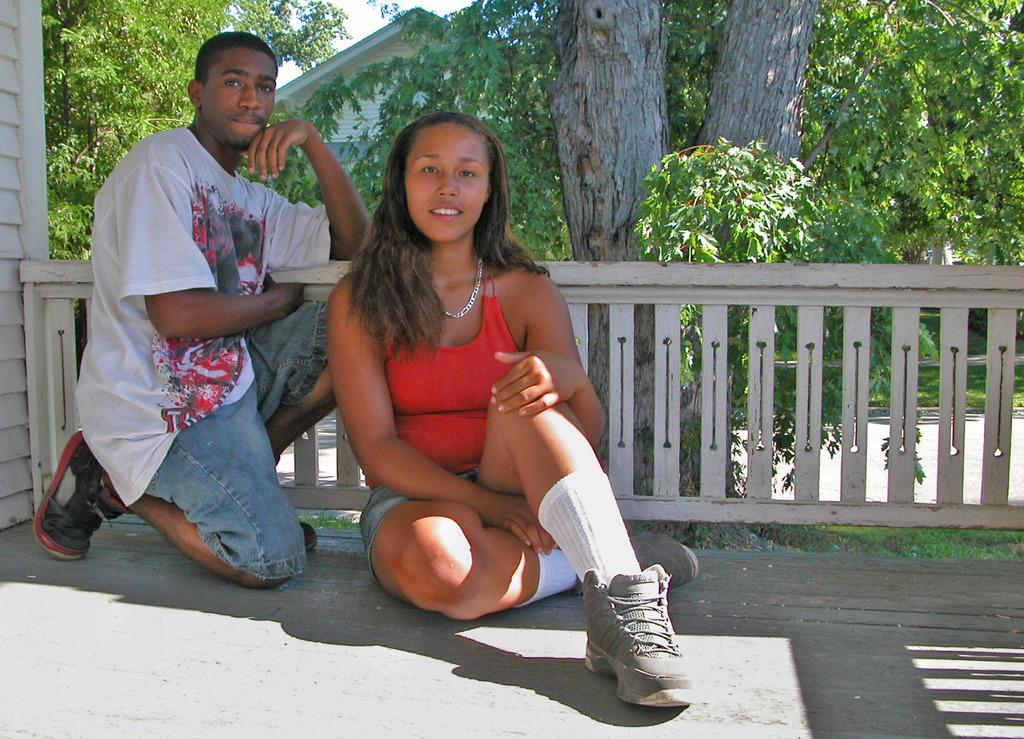How many people are in the image? There are two people in the image. What is one of the people doing in the image? One of the people is kneeling down. What is behind the two people in the image? There is a railing behind the two people. What can be seen in the background of the image? There are trees and a house in the background of the image. What type of sheep can be seen grazing on the dinner table in the image? There are no sheep or dinner table present in the image. What color is the silverware on the table in the image? There is no table or silverware present in the image. 